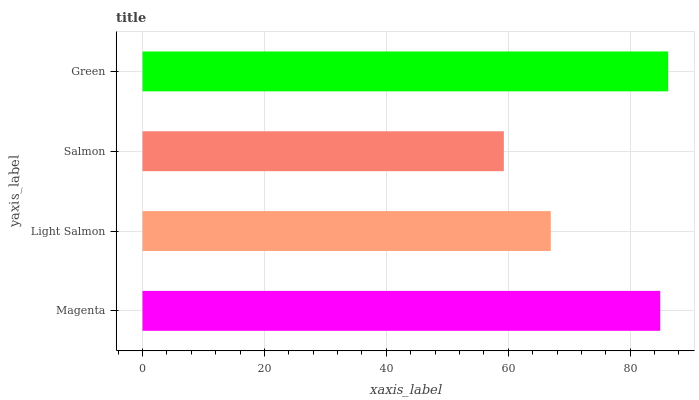Is Salmon the minimum?
Answer yes or no. Yes. Is Green the maximum?
Answer yes or no. Yes. Is Light Salmon the minimum?
Answer yes or no. No. Is Light Salmon the maximum?
Answer yes or no. No. Is Magenta greater than Light Salmon?
Answer yes or no. Yes. Is Light Salmon less than Magenta?
Answer yes or no. Yes. Is Light Salmon greater than Magenta?
Answer yes or no. No. Is Magenta less than Light Salmon?
Answer yes or no. No. Is Magenta the high median?
Answer yes or no. Yes. Is Light Salmon the low median?
Answer yes or no. Yes. Is Salmon the high median?
Answer yes or no. No. Is Salmon the low median?
Answer yes or no. No. 